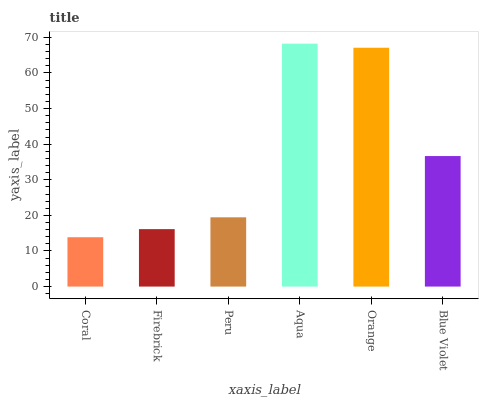Is Firebrick the minimum?
Answer yes or no. No. Is Firebrick the maximum?
Answer yes or no. No. Is Firebrick greater than Coral?
Answer yes or no. Yes. Is Coral less than Firebrick?
Answer yes or no. Yes. Is Coral greater than Firebrick?
Answer yes or no. No. Is Firebrick less than Coral?
Answer yes or no. No. Is Blue Violet the high median?
Answer yes or no. Yes. Is Peru the low median?
Answer yes or no. Yes. Is Orange the high median?
Answer yes or no. No. Is Orange the low median?
Answer yes or no. No. 